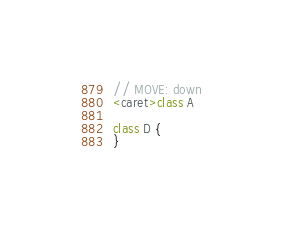<code> <loc_0><loc_0><loc_500><loc_500><_Kotlin_>// MOVE: down
<caret>class A

class D {
}</code> 